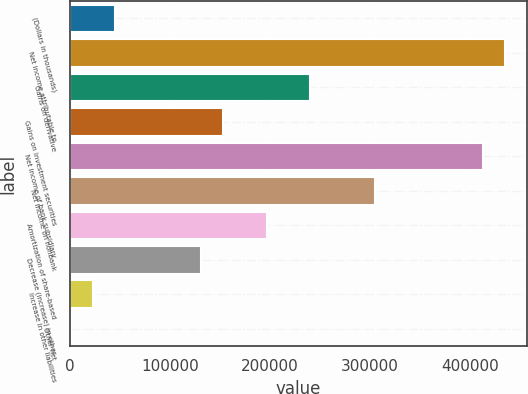Convert chart to OTSL. <chart><loc_0><loc_0><loc_500><loc_500><bar_chart><fcel>(Dollars in thousands)<fcel>Net income attributable to<fcel>Gains on derivative<fcel>Gains on investment securities<fcel>Net income of bank subsidiary<fcel>Net income on nonbank<fcel>Amortization of share-based<fcel>Decrease (increase) in other<fcel>Increase in other liabilities<fcel>Other net<nl><fcel>44644.8<fcel>435027<fcel>239836<fcel>153084<fcel>413339<fcel>304900<fcel>196460<fcel>131396<fcel>22956.9<fcel>1269<nl></chart> 